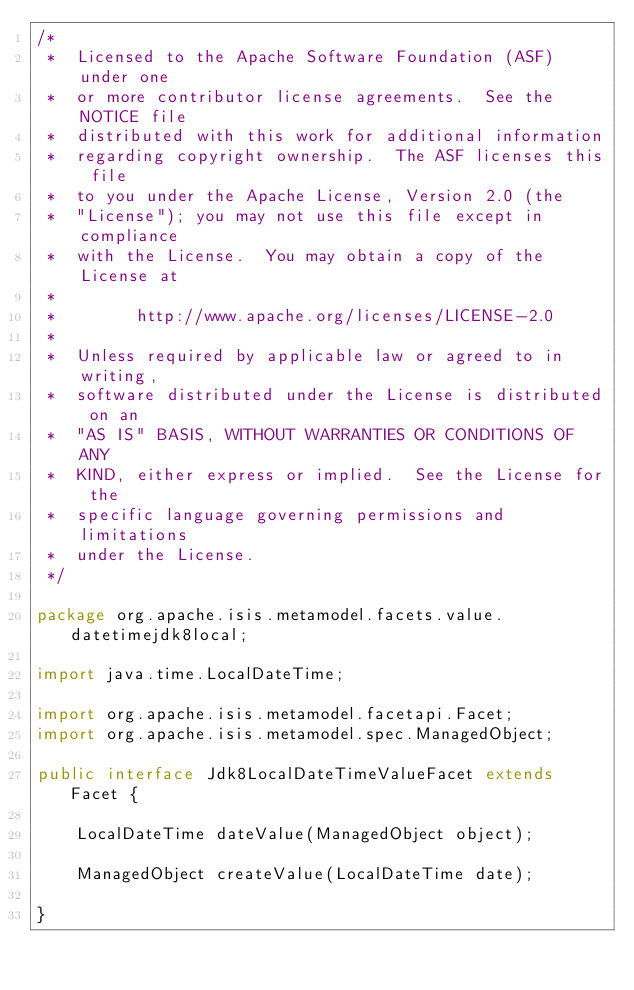<code> <loc_0><loc_0><loc_500><loc_500><_Java_>/*
 *  Licensed to the Apache Software Foundation (ASF) under one
 *  or more contributor license agreements.  See the NOTICE file
 *  distributed with this work for additional information
 *  regarding copyright ownership.  The ASF licenses this file
 *  to you under the Apache License, Version 2.0 (the
 *  "License"); you may not use this file except in compliance
 *  with the License.  You may obtain a copy of the License at
 *
 *        http://www.apache.org/licenses/LICENSE-2.0
 *
 *  Unless required by applicable law or agreed to in writing,
 *  software distributed under the License is distributed on an
 *  "AS IS" BASIS, WITHOUT WARRANTIES OR CONDITIONS OF ANY
 *  KIND, either express or implied.  See the License for the
 *  specific language governing permissions and limitations
 *  under the License.
 */

package org.apache.isis.metamodel.facets.value.datetimejdk8local;

import java.time.LocalDateTime;

import org.apache.isis.metamodel.facetapi.Facet;
import org.apache.isis.metamodel.spec.ManagedObject;

public interface Jdk8LocalDateTimeValueFacet extends Facet {

    LocalDateTime dateValue(ManagedObject object);

    ManagedObject createValue(LocalDateTime date);

}
</code> 